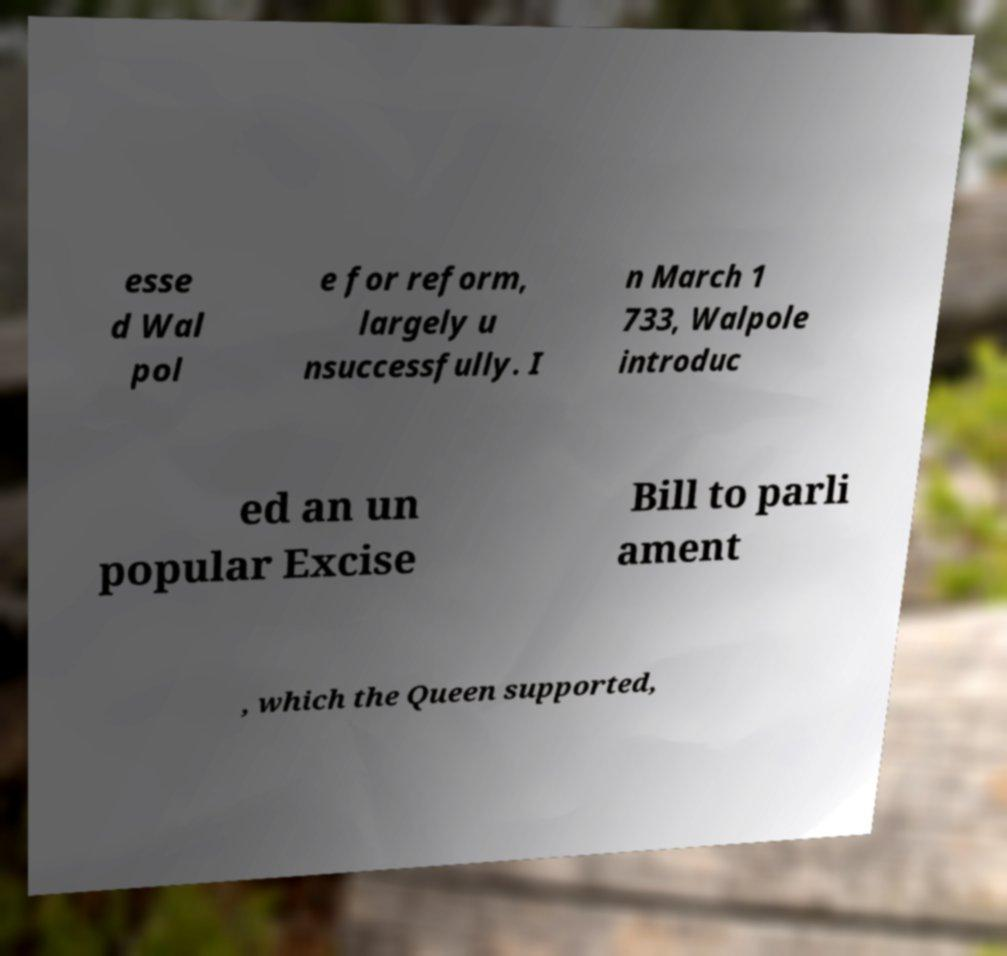Can you read and provide the text displayed in the image?This photo seems to have some interesting text. Can you extract and type it out for me? esse d Wal pol e for reform, largely u nsuccessfully. I n March 1 733, Walpole introduc ed an un popular Excise Bill to parli ament , which the Queen supported, 